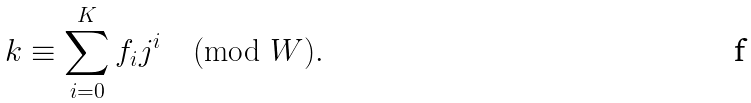Convert formula to latex. <formula><loc_0><loc_0><loc_500><loc_500>k \equiv \sum _ { i = 0 } ^ { K } f _ { i } j ^ { i } \pmod { W } .</formula> 